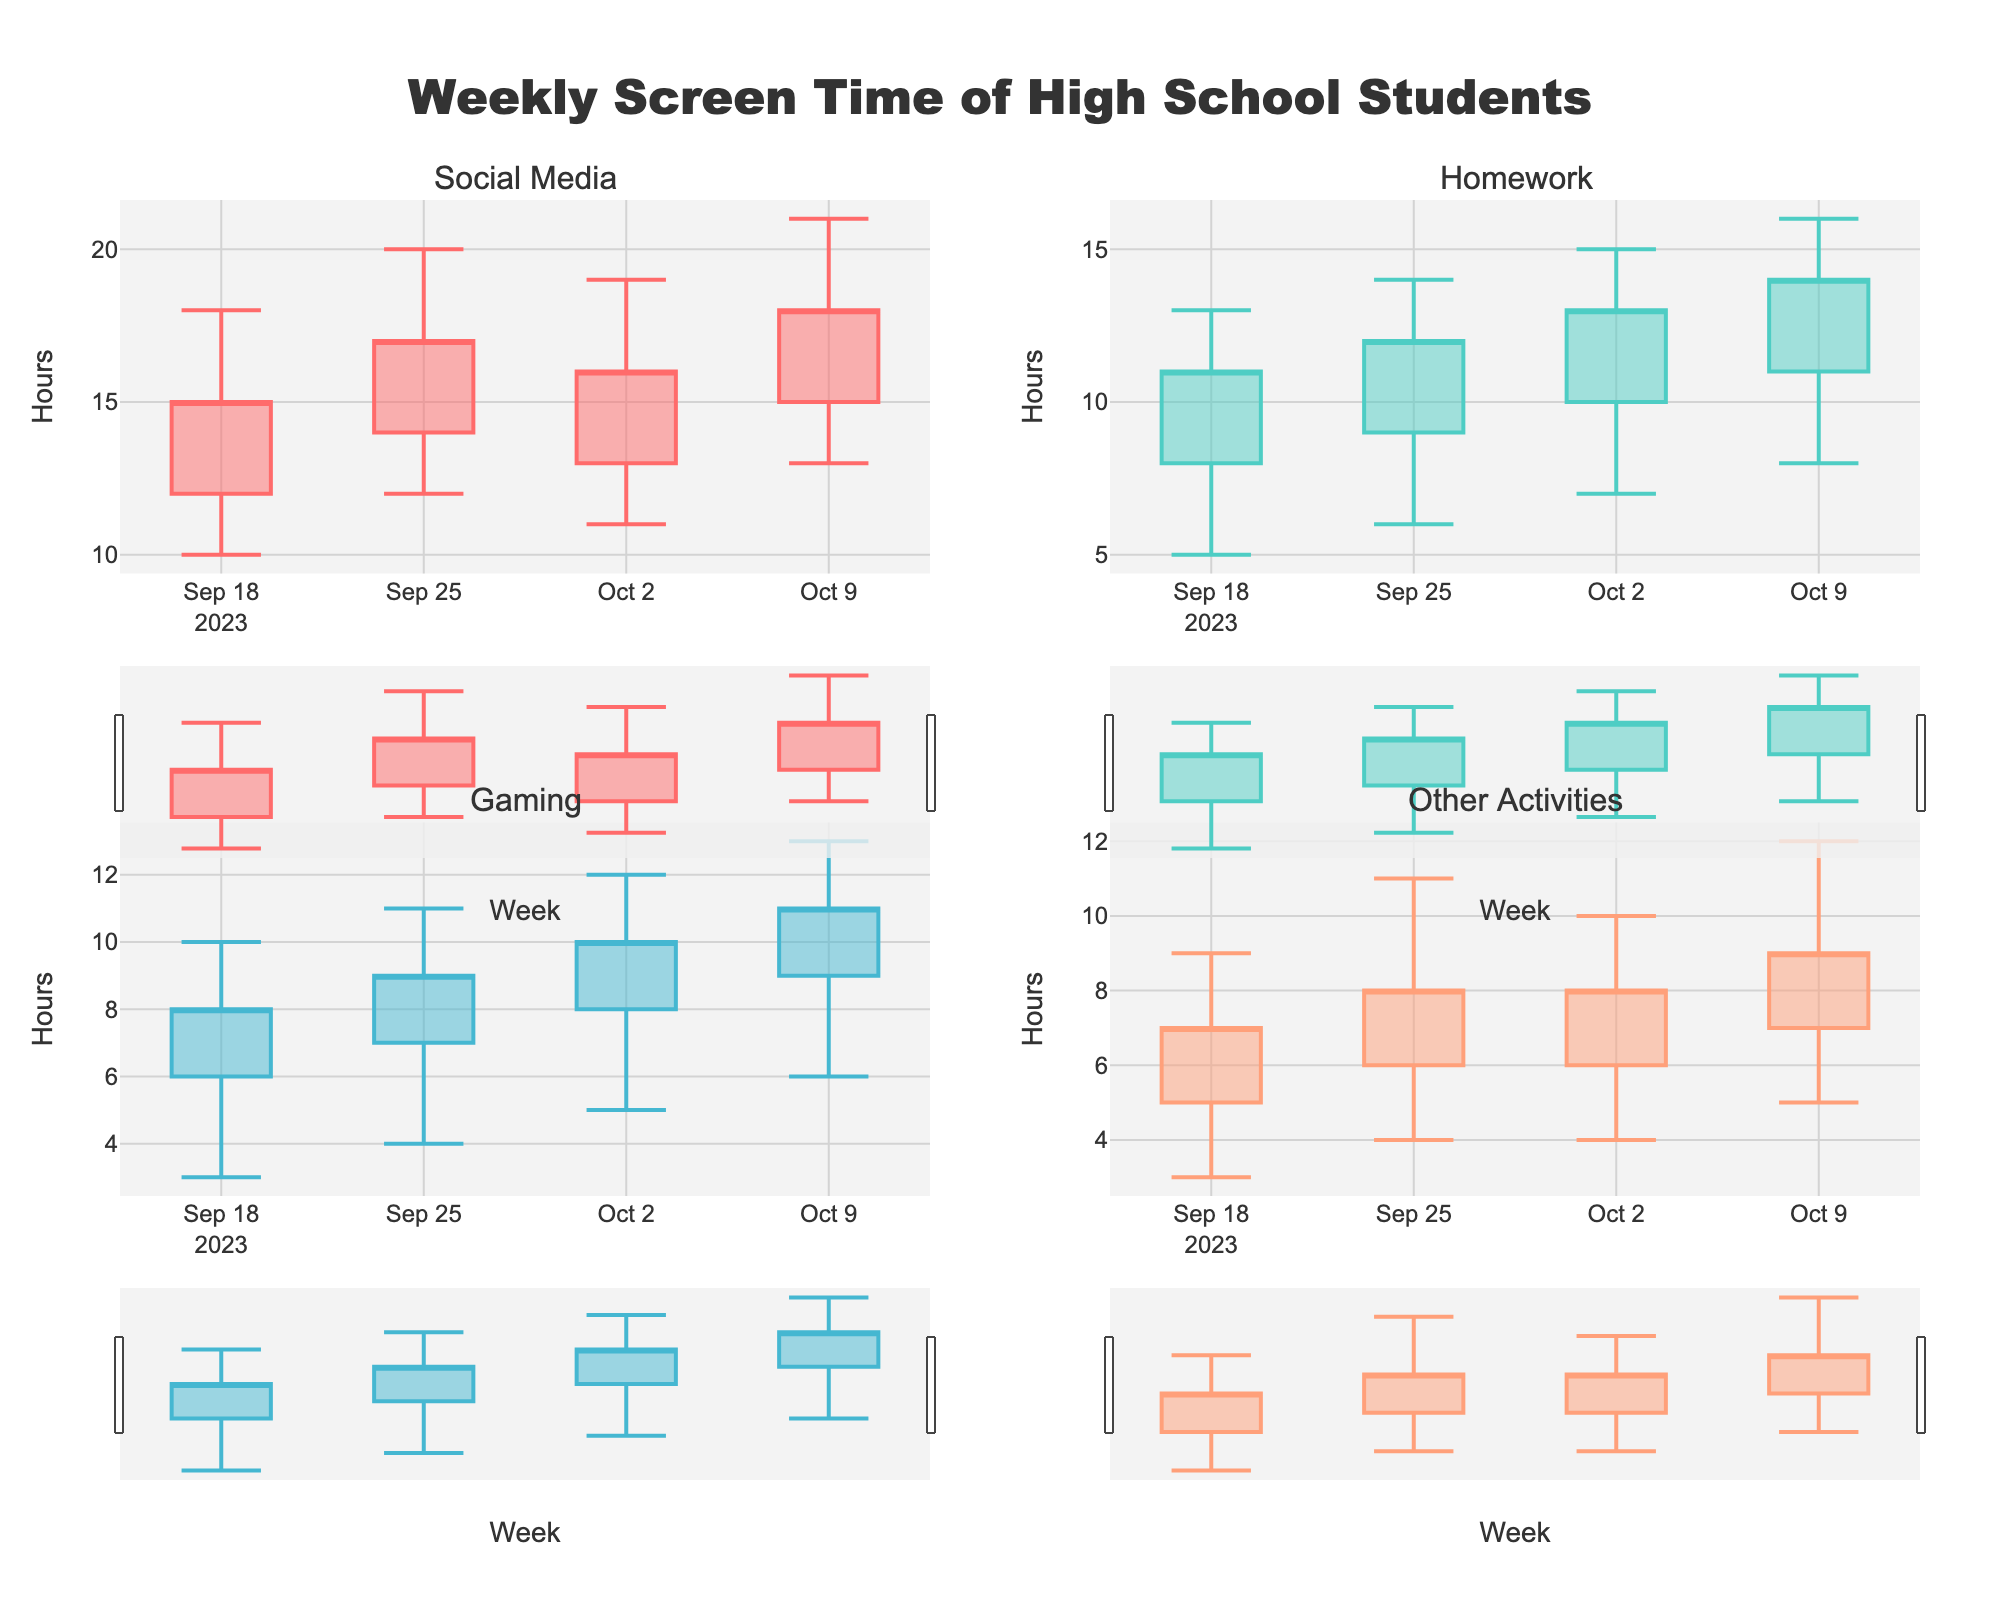What's the title of the figure? The title is usually located at the top of the figure. In this case, it states the subject being visualized.
Answer: Weekly Screen Time of High School Students Which category had the highest screen time during the week of 2023-09-18? To find the highest screen time for the week of 2023-09-18, look at each category and identify the highest value in the "High" column for that week.
Answer: Social Media What is the average closing screen time for Gaming over all the weeks? Add the closing values for Gaming from each week and then divide by the number of weeks: (8 + 9 + 10 + 11) / 4 = 38 / 4.
Answer: 9.5 hours How did the screen time for Homework change from the week of 2023-09-25 to 2023-10-02? Compare the closing screen time values for Homework from 2023-09-25 to 2023-10-02: 13 - 12 = 1 hour increase.
Answer: Increased by 1 hour Which category shows the least change in high screen time values over all weeks? Calculate the difference between the highest and lowest "High" values for each category and determine which one has the smallest range.
Answer: Other Activities During which week did Social Media have the largest difference between its high and low screen time values? For Social Media, calculate the difference between the high and low values for each week and identify the week with the largest difference.
Answer: 2023-10-09 What is the trend in closing screen time for Other Activities over the weeks? Observe the closing screen time values for Other Activities for each week in chronological order to determine if they are increasing, decreasing, or fluctuating.
Answer: Increasing Which category had the highest increase in opening screen time from the week of 2023-09-25 to 2023-10-02? Compare the opening screen time values between the weeks of 2023-09-25 and 2023-10-02 for each category and find the one with the highest increase.
Answer: Homework If the trend continues, what might you predict about the closing screen time for Gaming in the week following 2023-10-09? By observing the trend in closing screen time values for Gaming, infer if they are increasing or decreasing and predict the next value based on that trend (an upward or downward adjustment from the latest value, 11).
Answer: Likely to increase Which week had the most balanced screen time across all categories? Look for the week where the range between the highest and lowest closing screen time values across all categories is the smallest.
Answer: 2023-09-18 